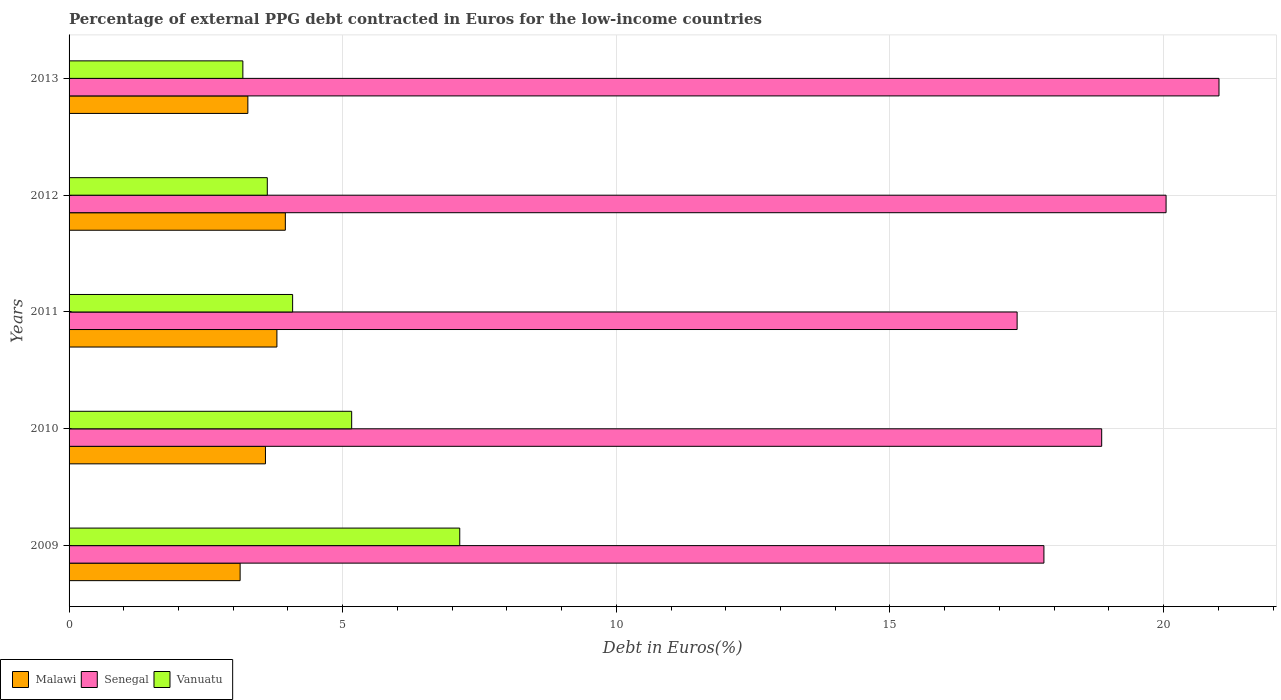How many groups of bars are there?
Give a very brief answer. 5. Are the number of bars per tick equal to the number of legend labels?
Your response must be concise. Yes. How many bars are there on the 3rd tick from the bottom?
Your response must be concise. 3. What is the percentage of external PPG debt contracted in Euros in Vanuatu in 2013?
Give a very brief answer. 3.18. Across all years, what is the maximum percentage of external PPG debt contracted in Euros in Malawi?
Provide a succinct answer. 3.95. Across all years, what is the minimum percentage of external PPG debt contracted in Euros in Senegal?
Provide a short and direct response. 17.32. In which year was the percentage of external PPG debt contracted in Euros in Senegal maximum?
Your response must be concise. 2013. What is the total percentage of external PPG debt contracted in Euros in Malawi in the graph?
Offer a very short reply. 17.73. What is the difference between the percentage of external PPG debt contracted in Euros in Vanuatu in 2009 and that in 2012?
Ensure brevity in your answer.  3.52. What is the difference between the percentage of external PPG debt contracted in Euros in Malawi in 2009 and the percentage of external PPG debt contracted in Euros in Vanuatu in 2012?
Your response must be concise. -0.5. What is the average percentage of external PPG debt contracted in Euros in Vanuatu per year?
Offer a terse response. 4.64. In the year 2009, what is the difference between the percentage of external PPG debt contracted in Euros in Senegal and percentage of external PPG debt contracted in Euros in Malawi?
Your answer should be compact. 14.69. What is the ratio of the percentage of external PPG debt contracted in Euros in Senegal in 2012 to that in 2013?
Provide a short and direct response. 0.95. Is the percentage of external PPG debt contracted in Euros in Malawi in 2010 less than that in 2012?
Provide a succinct answer. Yes. What is the difference between the highest and the second highest percentage of external PPG debt contracted in Euros in Senegal?
Offer a terse response. 0.97. What is the difference between the highest and the lowest percentage of external PPG debt contracted in Euros in Senegal?
Your answer should be compact. 3.69. In how many years, is the percentage of external PPG debt contracted in Euros in Malawi greater than the average percentage of external PPG debt contracted in Euros in Malawi taken over all years?
Keep it short and to the point. 3. Is the sum of the percentage of external PPG debt contracted in Euros in Malawi in 2010 and 2011 greater than the maximum percentage of external PPG debt contracted in Euros in Vanuatu across all years?
Your response must be concise. Yes. What does the 1st bar from the top in 2010 represents?
Provide a succinct answer. Vanuatu. What does the 1st bar from the bottom in 2013 represents?
Keep it short and to the point. Malawi. Are all the bars in the graph horizontal?
Give a very brief answer. Yes. How many years are there in the graph?
Your answer should be very brief. 5. Does the graph contain grids?
Give a very brief answer. Yes. How many legend labels are there?
Your answer should be very brief. 3. How are the legend labels stacked?
Your response must be concise. Horizontal. What is the title of the graph?
Your answer should be very brief. Percentage of external PPG debt contracted in Euros for the low-income countries. What is the label or title of the X-axis?
Keep it short and to the point. Debt in Euros(%). What is the Debt in Euros(%) in Malawi in 2009?
Your response must be concise. 3.13. What is the Debt in Euros(%) of Senegal in 2009?
Make the answer very short. 17.81. What is the Debt in Euros(%) of Vanuatu in 2009?
Your answer should be very brief. 7.14. What is the Debt in Euros(%) of Malawi in 2010?
Give a very brief answer. 3.59. What is the Debt in Euros(%) of Senegal in 2010?
Give a very brief answer. 18.87. What is the Debt in Euros(%) in Vanuatu in 2010?
Make the answer very short. 5.16. What is the Debt in Euros(%) of Malawi in 2011?
Your response must be concise. 3.8. What is the Debt in Euros(%) in Senegal in 2011?
Offer a very short reply. 17.32. What is the Debt in Euros(%) in Vanuatu in 2011?
Your answer should be compact. 4.08. What is the Debt in Euros(%) of Malawi in 2012?
Your answer should be compact. 3.95. What is the Debt in Euros(%) in Senegal in 2012?
Make the answer very short. 20.05. What is the Debt in Euros(%) in Vanuatu in 2012?
Provide a short and direct response. 3.62. What is the Debt in Euros(%) in Malawi in 2013?
Your answer should be compact. 3.27. What is the Debt in Euros(%) of Senegal in 2013?
Provide a short and direct response. 21.01. What is the Debt in Euros(%) in Vanuatu in 2013?
Offer a very short reply. 3.18. Across all years, what is the maximum Debt in Euros(%) in Malawi?
Ensure brevity in your answer.  3.95. Across all years, what is the maximum Debt in Euros(%) in Senegal?
Make the answer very short. 21.01. Across all years, what is the maximum Debt in Euros(%) in Vanuatu?
Your answer should be compact. 7.14. Across all years, what is the minimum Debt in Euros(%) in Malawi?
Provide a succinct answer. 3.13. Across all years, what is the minimum Debt in Euros(%) of Senegal?
Provide a succinct answer. 17.32. Across all years, what is the minimum Debt in Euros(%) of Vanuatu?
Offer a very short reply. 3.18. What is the total Debt in Euros(%) of Malawi in the graph?
Ensure brevity in your answer.  17.73. What is the total Debt in Euros(%) of Senegal in the graph?
Your answer should be compact. 95.07. What is the total Debt in Euros(%) of Vanuatu in the graph?
Offer a very short reply. 23.19. What is the difference between the Debt in Euros(%) of Malawi in 2009 and that in 2010?
Your answer should be very brief. -0.46. What is the difference between the Debt in Euros(%) in Senegal in 2009 and that in 2010?
Your answer should be compact. -1.06. What is the difference between the Debt in Euros(%) in Vanuatu in 2009 and that in 2010?
Offer a very short reply. 1.97. What is the difference between the Debt in Euros(%) of Malawi in 2009 and that in 2011?
Your response must be concise. -0.67. What is the difference between the Debt in Euros(%) in Senegal in 2009 and that in 2011?
Offer a very short reply. 0.49. What is the difference between the Debt in Euros(%) in Vanuatu in 2009 and that in 2011?
Offer a terse response. 3.05. What is the difference between the Debt in Euros(%) of Malawi in 2009 and that in 2012?
Your answer should be compact. -0.83. What is the difference between the Debt in Euros(%) of Senegal in 2009 and that in 2012?
Your answer should be very brief. -2.23. What is the difference between the Debt in Euros(%) of Vanuatu in 2009 and that in 2012?
Your response must be concise. 3.52. What is the difference between the Debt in Euros(%) in Malawi in 2009 and that in 2013?
Your answer should be very brief. -0.14. What is the difference between the Debt in Euros(%) of Senegal in 2009 and that in 2013?
Give a very brief answer. -3.2. What is the difference between the Debt in Euros(%) in Vanuatu in 2009 and that in 2013?
Give a very brief answer. 3.96. What is the difference between the Debt in Euros(%) in Malawi in 2010 and that in 2011?
Ensure brevity in your answer.  -0.21. What is the difference between the Debt in Euros(%) in Senegal in 2010 and that in 2011?
Keep it short and to the point. 1.55. What is the difference between the Debt in Euros(%) in Vanuatu in 2010 and that in 2011?
Keep it short and to the point. 1.08. What is the difference between the Debt in Euros(%) in Malawi in 2010 and that in 2012?
Provide a succinct answer. -0.36. What is the difference between the Debt in Euros(%) of Senegal in 2010 and that in 2012?
Keep it short and to the point. -1.18. What is the difference between the Debt in Euros(%) of Vanuatu in 2010 and that in 2012?
Offer a very short reply. 1.54. What is the difference between the Debt in Euros(%) in Malawi in 2010 and that in 2013?
Ensure brevity in your answer.  0.32. What is the difference between the Debt in Euros(%) in Senegal in 2010 and that in 2013?
Keep it short and to the point. -2.14. What is the difference between the Debt in Euros(%) in Vanuatu in 2010 and that in 2013?
Make the answer very short. 1.99. What is the difference between the Debt in Euros(%) in Malawi in 2011 and that in 2012?
Keep it short and to the point. -0.15. What is the difference between the Debt in Euros(%) in Senegal in 2011 and that in 2012?
Your response must be concise. -2.72. What is the difference between the Debt in Euros(%) of Vanuatu in 2011 and that in 2012?
Your answer should be compact. 0.46. What is the difference between the Debt in Euros(%) of Malawi in 2011 and that in 2013?
Your answer should be very brief. 0.53. What is the difference between the Debt in Euros(%) of Senegal in 2011 and that in 2013?
Your answer should be compact. -3.69. What is the difference between the Debt in Euros(%) of Vanuatu in 2011 and that in 2013?
Your answer should be compact. 0.91. What is the difference between the Debt in Euros(%) in Malawi in 2012 and that in 2013?
Give a very brief answer. 0.69. What is the difference between the Debt in Euros(%) in Senegal in 2012 and that in 2013?
Offer a terse response. -0.97. What is the difference between the Debt in Euros(%) in Vanuatu in 2012 and that in 2013?
Keep it short and to the point. 0.45. What is the difference between the Debt in Euros(%) in Malawi in 2009 and the Debt in Euros(%) in Senegal in 2010?
Offer a terse response. -15.74. What is the difference between the Debt in Euros(%) of Malawi in 2009 and the Debt in Euros(%) of Vanuatu in 2010?
Offer a terse response. -2.04. What is the difference between the Debt in Euros(%) of Senegal in 2009 and the Debt in Euros(%) of Vanuatu in 2010?
Make the answer very short. 12.65. What is the difference between the Debt in Euros(%) in Malawi in 2009 and the Debt in Euros(%) in Senegal in 2011?
Offer a terse response. -14.2. What is the difference between the Debt in Euros(%) in Malawi in 2009 and the Debt in Euros(%) in Vanuatu in 2011?
Give a very brief answer. -0.96. What is the difference between the Debt in Euros(%) in Senegal in 2009 and the Debt in Euros(%) in Vanuatu in 2011?
Provide a short and direct response. 13.73. What is the difference between the Debt in Euros(%) in Malawi in 2009 and the Debt in Euros(%) in Senegal in 2012?
Your answer should be compact. -16.92. What is the difference between the Debt in Euros(%) of Malawi in 2009 and the Debt in Euros(%) of Vanuatu in 2012?
Provide a short and direct response. -0.5. What is the difference between the Debt in Euros(%) of Senegal in 2009 and the Debt in Euros(%) of Vanuatu in 2012?
Provide a short and direct response. 14.19. What is the difference between the Debt in Euros(%) in Malawi in 2009 and the Debt in Euros(%) in Senegal in 2013?
Offer a very short reply. -17.89. What is the difference between the Debt in Euros(%) of Malawi in 2009 and the Debt in Euros(%) of Vanuatu in 2013?
Offer a terse response. -0.05. What is the difference between the Debt in Euros(%) in Senegal in 2009 and the Debt in Euros(%) in Vanuatu in 2013?
Make the answer very short. 14.64. What is the difference between the Debt in Euros(%) of Malawi in 2010 and the Debt in Euros(%) of Senegal in 2011?
Ensure brevity in your answer.  -13.74. What is the difference between the Debt in Euros(%) in Malawi in 2010 and the Debt in Euros(%) in Vanuatu in 2011?
Your answer should be very brief. -0.5. What is the difference between the Debt in Euros(%) in Senegal in 2010 and the Debt in Euros(%) in Vanuatu in 2011?
Provide a succinct answer. 14.78. What is the difference between the Debt in Euros(%) of Malawi in 2010 and the Debt in Euros(%) of Senegal in 2012?
Your response must be concise. -16.46. What is the difference between the Debt in Euros(%) in Malawi in 2010 and the Debt in Euros(%) in Vanuatu in 2012?
Your answer should be very brief. -0.03. What is the difference between the Debt in Euros(%) in Senegal in 2010 and the Debt in Euros(%) in Vanuatu in 2012?
Provide a short and direct response. 15.25. What is the difference between the Debt in Euros(%) in Malawi in 2010 and the Debt in Euros(%) in Senegal in 2013?
Give a very brief answer. -17.42. What is the difference between the Debt in Euros(%) in Malawi in 2010 and the Debt in Euros(%) in Vanuatu in 2013?
Ensure brevity in your answer.  0.41. What is the difference between the Debt in Euros(%) in Senegal in 2010 and the Debt in Euros(%) in Vanuatu in 2013?
Give a very brief answer. 15.69. What is the difference between the Debt in Euros(%) of Malawi in 2011 and the Debt in Euros(%) of Senegal in 2012?
Keep it short and to the point. -16.25. What is the difference between the Debt in Euros(%) of Malawi in 2011 and the Debt in Euros(%) of Vanuatu in 2012?
Ensure brevity in your answer.  0.18. What is the difference between the Debt in Euros(%) in Senegal in 2011 and the Debt in Euros(%) in Vanuatu in 2012?
Provide a succinct answer. 13.7. What is the difference between the Debt in Euros(%) in Malawi in 2011 and the Debt in Euros(%) in Senegal in 2013?
Your answer should be compact. -17.22. What is the difference between the Debt in Euros(%) of Malawi in 2011 and the Debt in Euros(%) of Vanuatu in 2013?
Make the answer very short. 0.62. What is the difference between the Debt in Euros(%) in Senegal in 2011 and the Debt in Euros(%) in Vanuatu in 2013?
Provide a short and direct response. 14.15. What is the difference between the Debt in Euros(%) of Malawi in 2012 and the Debt in Euros(%) of Senegal in 2013?
Offer a very short reply. -17.06. What is the difference between the Debt in Euros(%) in Malawi in 2012 and the Debt in Euros(%) in Vanuatu in 2013?
Ensure brevity in your answer.  0.78. What is the difference between the Debt in Euros(%) in Senegal in 2012 and the Debt in Euros(%) in Vanuatu in 2013?
Offer a very short reply. 16.87. What is the average Debt in Euros(%) of Malawi per year?
Your response must be concise. 3.55. What is the average Debt in Euros(%) in Senegal per year?
Ensure brevity in your answer.  19.01. What is the average Debt in Euros(%) in Vanuatu per year?
Your answer should be very brief. 4.64. In the year 2009, what is the difference between the Debt in Euros(%) in Malawi and Debt in Euros(%) in Senegal?
Your response must be concise. -14.69. In the year 2009, what is the difference between the Debt in Euros(%) in Malawi and Debt in Euros(%) in Vanuatu?
Provide a succinct answer. -4.01. In the year 2009, what is the difference between the Debt in Euros(%) of Senegal and Debt in Euros(%) of Vanuatu?
Your response must be concise. 10.68. In the year 2010, what is the difference between the Debt in Euros(%) in Malawi and Debt in Euros(%) in Senegal?
Your response must be concise. -15.28. In the year 2010, what is the difference between the Debt in Euros(%) of Malawi and Debt in Euros(%) of Vanuatu?
Provide a short and direct response. -1.58. In the year 2010, what is the difference between the Debt in Euros(%) of Senegal and Debt in Euros(%) of Vanuatu?
Provide a succinct answer. 13.71. In the year 2011, what is the difference between the Debt in Euros(%) in Malawi and Debt in Euros(%) in Senegal?
Give a very brief answer. -13.53. In the year 2011, what is the difference between the Debt in Euros(%) in Malawi and Debt in Euros(%) in Vanuatu?
Give a very brief answer. -0.29. In the year 2011, what is the difference between the Debt in Euros(%) in Senegal and Debt in Euros(%) in Vanuatu?
Your answer should be very brief. 13.24. In the year 2012, what is the difference between the Debt in Euros(%) in Malawi and Debt in Euros(%) in Senegal?
Your answer should be compact. -16.09. In the year 2012, what is the difference between the Debt in Euros(%) of Malawi and Debt in Euros(%) of Vanuatu?
Your answer should be compact. 0.33. In the year 2012, what is the difference between the Debt in Euros(%) in Senegal and Debt in Euros(%) in Vanuatu?
Give a very brief answer. 16.42. In the year 2013, what is the difference between the Debt in Euros(%) in Malawi and Debt in Euros(%) in Senegal?
Provide a succinct answer. -17.75. In the year 2013, what is the difference between the Debt in Euros(%) in Malawi and Debt in Euros(%) in Vanuatu?
Offer a terse response. 0.09. In the year 2013, what is the difference between the Debt in Euros(%) in Senegal and Debt in Euros(%) in Vanuatu?
Give a very brief answer. 17.84. What is the ratio of the Debt in Euros(%) in Malawi in 2009 to that in 2010?
Provide a succinct answer. 0.87. What is the ratio of the Debt in Euros(%) in Senegal in 2009 to that in 2010?
Your answer should be compact. 0.94. What is the ratio of the Debt in Euros(%) in Vanuatu in 2009 to that in 2010?
Keep it short and to the point. 1.38. What is the ratio of the Debt in Euros(%) of Malawi in 2009 to that in 2011?
Offer a very short reply. 0.82. What is the ratio of the Debt in Euros(%) in Senegal in 2009 to that in 2011?
Keep it short and to the point. 1.03. What is the ratio of the Debt in Euros(%) in Vanuatu in 2009 to that in 2011?
Make the answer very short. 1.75. What is the ratio of the Debt in Euros(%) in Malawi in 2009 to that in 2012?
Give a very brief answer. 0.79. What is the ratio of the Debt in Euros(%) in Senegal in 2009 to that in 2012?
Offer a terse response. 0.89. What is the ratio of the Debt in Euros(%) in Vanuatu in 2009 to that in 2012?
Your answer should be very brief. 1.97. What is the ratio of the Debt in Euros(%) of Malawi in 2009 to that in 2013?
Give a very brief answer. 0.96. What is the ratio of the Debt in Euros(%) of Senegal in 2009 to that in 2013?
Your answer should be compact. 0.85. What is the ratio of the Debt in Euros(%) of Vanuatu in 2009 to that in 2013?
Keep it short and to the point. 2.25. What is the ratio of the Debt in Euros(%) in Malawi in 2010 to that in 2011?
Make the answer very short. 0.94. What is the ratio of the Debt in Euros(%) in Senegal in 2010 to that in 2011?
Ensure brevity in your answer.  1.09. What is the ratio of the Debt in Euros(%) in Vanuatu in 2010 to that in 2011?
Your answer should be very brief. 1.26. What is the ratio of the Debt in Euros(%) of Malawi in 2010 to that in 2012?
Provide a succinct answer. 0.91. What is the ratio of the Debt in Euros(%) in Senegal in 2010 to that in 2012?
Give a very brief answer. 0.94. What is the ratio of the Debt in Euros(%) in Vanuatu in 2010 to that in 2012?
Ensure brevity in your answer.  1.43. What is the ratio of the Debt in Euros(%) of Malawi in 2010 to that in 2013?
Your answer should be very brief. 1.1. What is the ratio of the Debt in Euros(%) in Senegal in 2010 to that in 2013?
Offer a terse response. 0.9. What is the ratio of the Debt in Euros(%) of Vanuatu in 2010 to that in 2013?
Make the answer very short. 1.63. What is the ratio of the Debt in Euros(%) of Malawi in 2011 to that in 2012?
Give a very brief answer. 0.96. What is the ratio of the Debt in Euros(%) of Senegal in 2011 to that in 2012?
Make the answer very short. 0.86. What is the ratio of the Debt in Euros(%) of Vanuatu in 2011 to that in 2012?
Offer a terse response. 1.13. What is the ratio of the Debt in Euros(%) of Malawi in 2011 to that in 2013?
Your answer should be compact. 1.16. What is the ratio of the Debt in Euros(%) of Senegal in 2011 to that in 2013?
Your answer should be compact. 0.82. What is the ratio of the Debt in Euros(%) in Vanuatu in 2011 to that in 2013?
Give a very brief answer. 1.29. What is the ratio of the Debt in Euros(%) in Malawi in 2012 to that in 2013?
Make the answer very short. 1.21. What is the ratio of the Debt in Euros(%) in Senegal in 2012 to that in 2013?
Offer a terse response. 0.95. What is the ratio of the Debt in Euros(%) in Vanuatu in 2012 to that in 2013?
Your answer should be compact. 1.14. What is the difference between the highest and the second highest Debt in Euros(%) of Malawi?
Make the answer very short. 0.15. What is the difference between the highest and the second highest Debt in Euros(%) of Vanuatu?
Give a very brief answer. 1.97. What is the difference between the highest and the lowest Debt in Euros(%) of Malawi?
Your answer should be very brief. 0.83. What is the difference between the highest and the lowest Debt in Euros(%) in Senegal?
Keep it short and to the point. 3.69. What is the difference between the highest and the lowest Debt in Euros(%) of Vanuatu?
Provide a succinct answer. 3.96. 